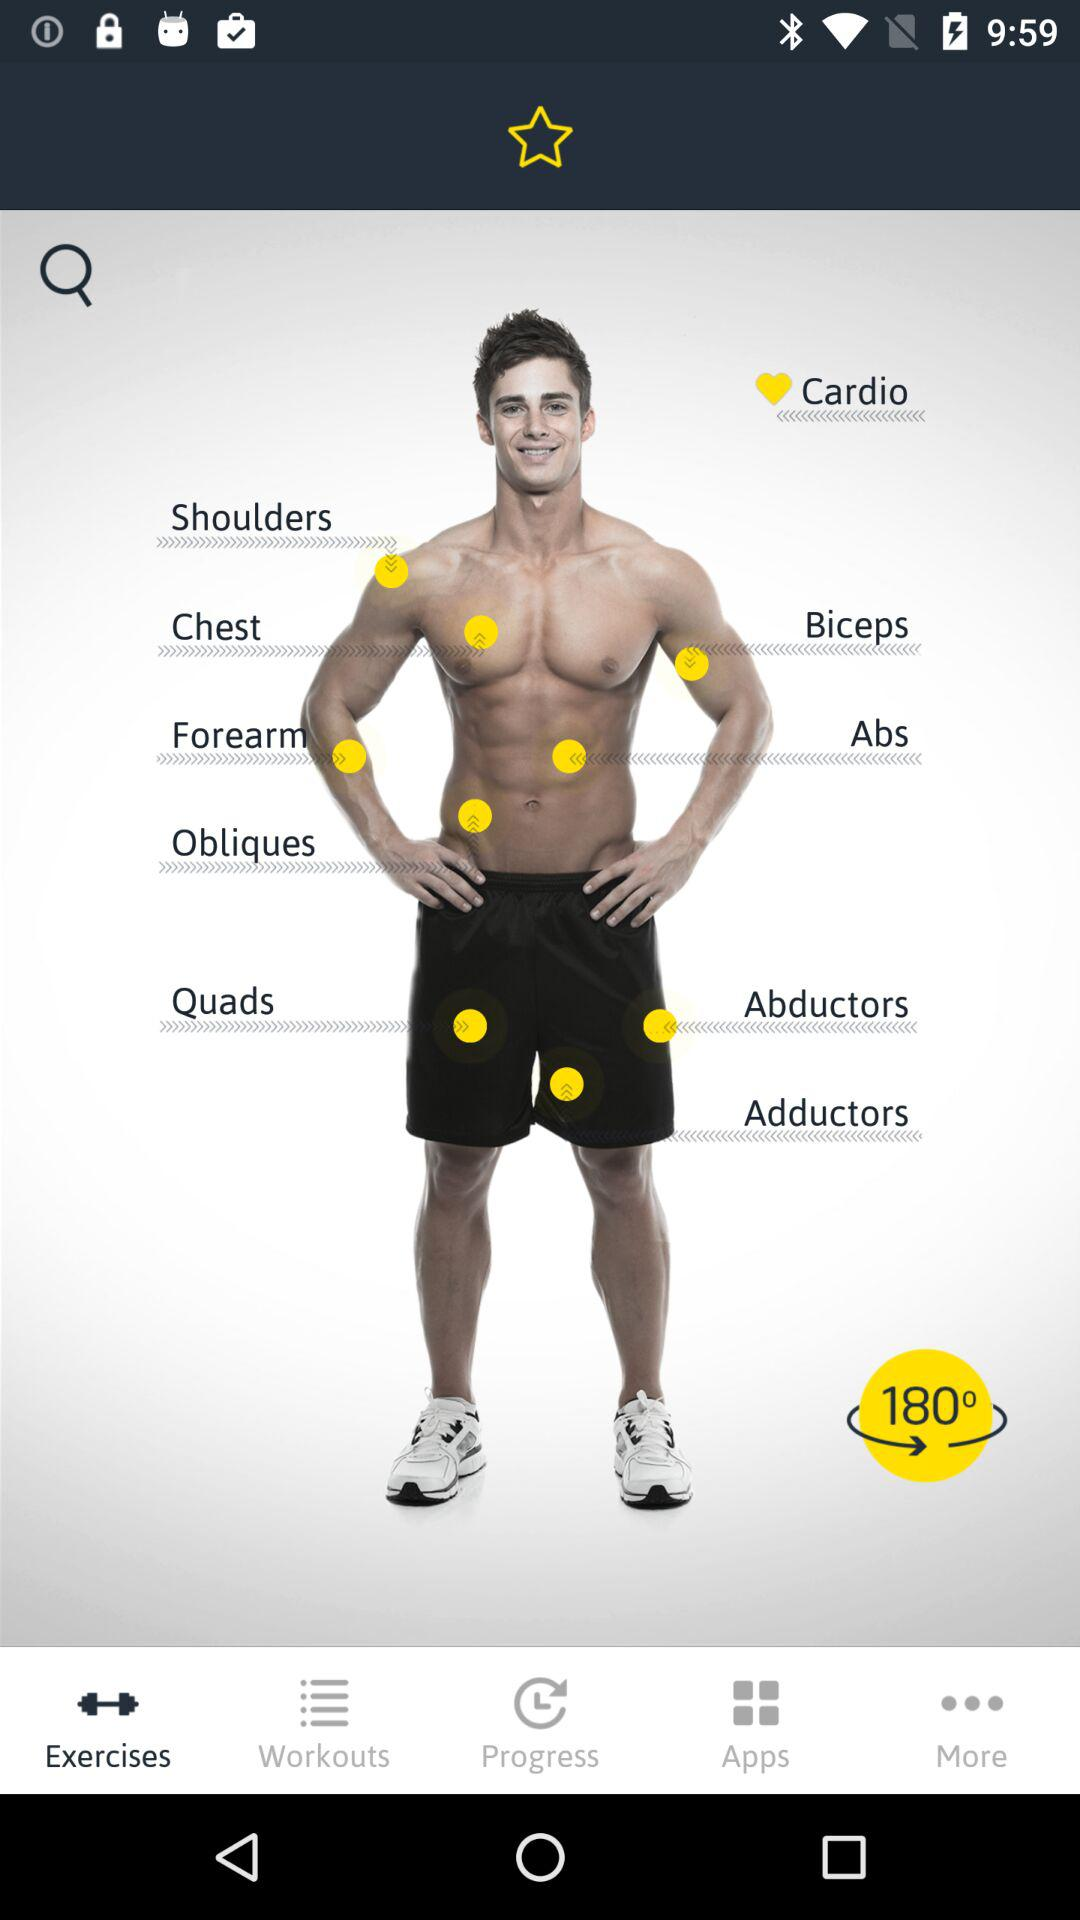Which tab is selected? The selected tab is "Exercises". 